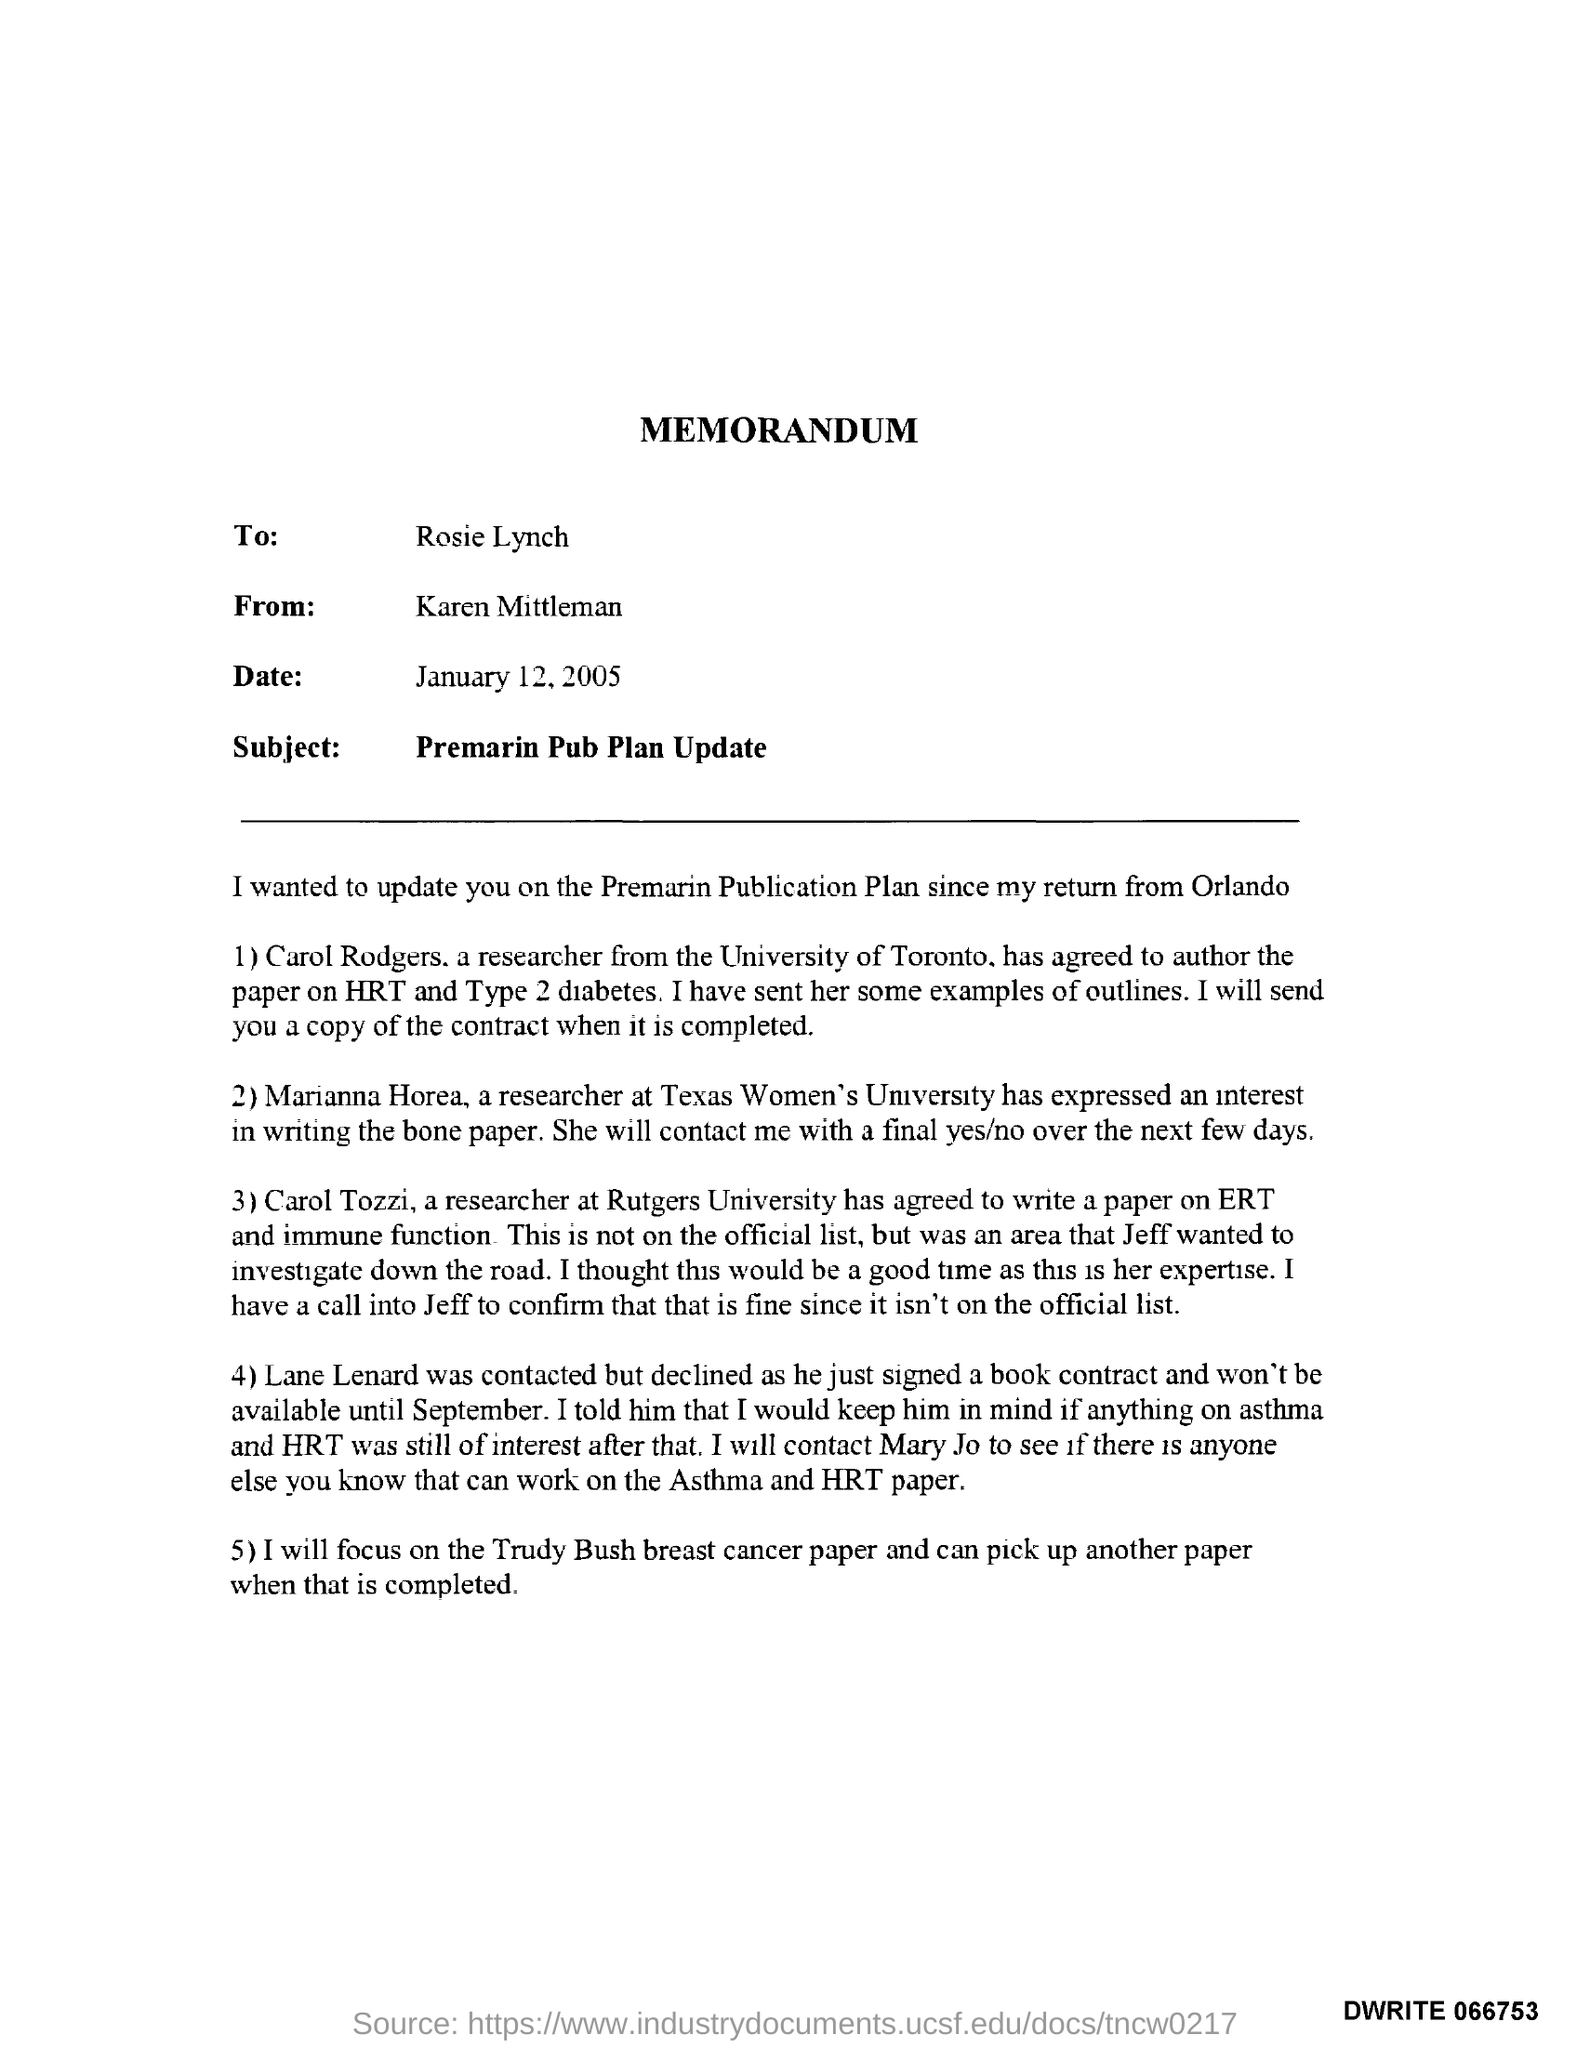What is the subject of memorandum ?
Ensure brevity in your answer.  Premarin Pub Plan Update. Who sent this memorandum?
Make the answer very short. Karen Mittleman. Which contract signed by Lane Lenard?
Your answer should be very brief. Book contract. Which paper Rosie will focus?
Keep it short and to the point. Trudy Bush breast cancer paper. Who is Carol Tozzi?
Your answer should be compact. A researcher at rutgers university. 